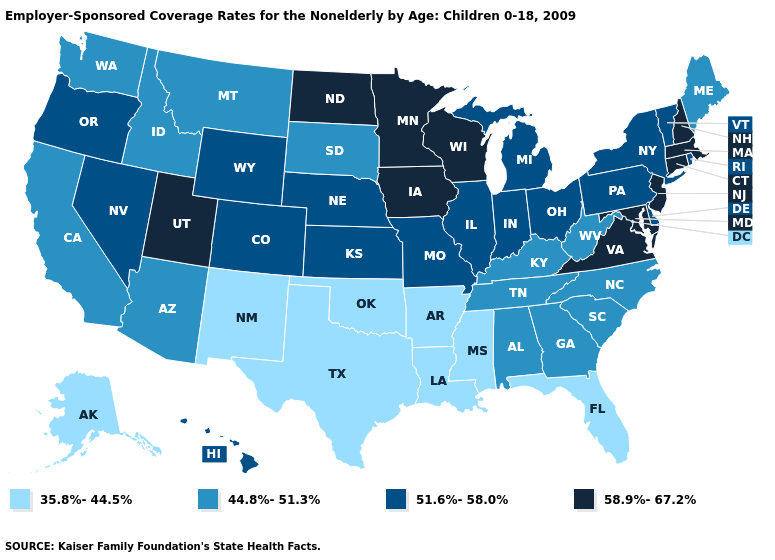What is the value of Kentucky?
Short answer required. 44.8%-51.3%. What is the value of Kansas?
Be succinct. 51.6%-58.0%. Among the states that border Iowa , does Illinois have the highest value?
Short answer required. No. What is the value of Alaska?
Write a very short answer. 35.8%-44.5%. Name the states that have a value in the range 44.8%-51.3%?
Write a very short answer. Alabama, Arizona, California, Georgia, Idaho, Kentucky, Maine, Montana, North Carolina, South Carolina, South Dakota, Tennessee, Washington, West Virginia. Which states hav the highest value in the South?
Write a very short answer. Maryland, Virginia. What is the highest value in states that border Mississippi?
Be succinct. 44.8%-51.3%. What is the highest value in the MidWest ?
Be succinct. 58.9%-67.2%. Name the states that have a value in the range 58.9%-67.2%?
Keep it brief. Connecticut, Iowa, Maryland, Massachusetts, Minnesota, New Hampshire, New Jersey, North Dakota, Utah, Virginia, Wisconsin. Among the states that border Ohio , which have the highest value?
Give a very brief answer. Indiana, Michigan, Pennsylvania. Does Minnesota have a higher value than New Jersey?
Write a very short answer. No. What is the value of Kansas?
Give a very brief answer. 51.6%-58.0%. What is the value of Maine?
Be succinct. 44.8%-51.3%. What is the lowest value in the USA?
Short answer required. 35.8%-44.5%. 